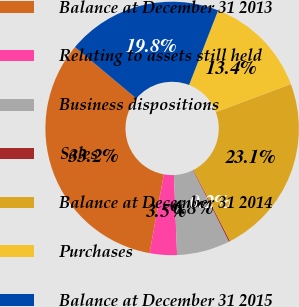Convert chart to OTSL. <chart><loc_0><loc_0><loc_500><loc_500><pie_chart><fcel>Balance at December 31 2013<fcel>Relating to assets still held<fcel>Business dispositions<fcel>Sales<fcel>Balance at December 31 2014<fcel>Purchases<fcel>Balance at December 31 2015<nl><fcel>33.25%<fcel>3.47%<fcel>6.78%<fcel>0.16%<fcel>23.13%<fcel>13.4%<fcel>19.82%<nl></chart> 